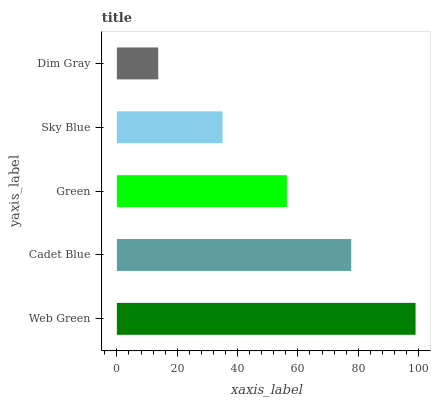Is Dim Gray the minimum?
Answer yes or no. Yes. Is Web Green the maximum?
Answer yes or no. Yes. Is Cadet Blue the minimum?
Answer yes or no. No. Is Cadet Blue the maximum?
Answer yes or no. No. Is Web Green greater than Cadet Blue?
Answer yes or no. Yes. Is Cadet Blue less than Web Green?
Answer yes or no. Yes. Is Cadet Blue greater than Web Green?
Answer yes or no. No. Is Web Green less than Cadet Blue?
Answer yes or no. No. Is Green the high median?
Answer yes or no. Yes. Is Green the low median?
Answer yes or no. Yes. Is Web Green the high median?
Answer yes or no. No. Is Web Green the low median?
Answer yes or no. No. 